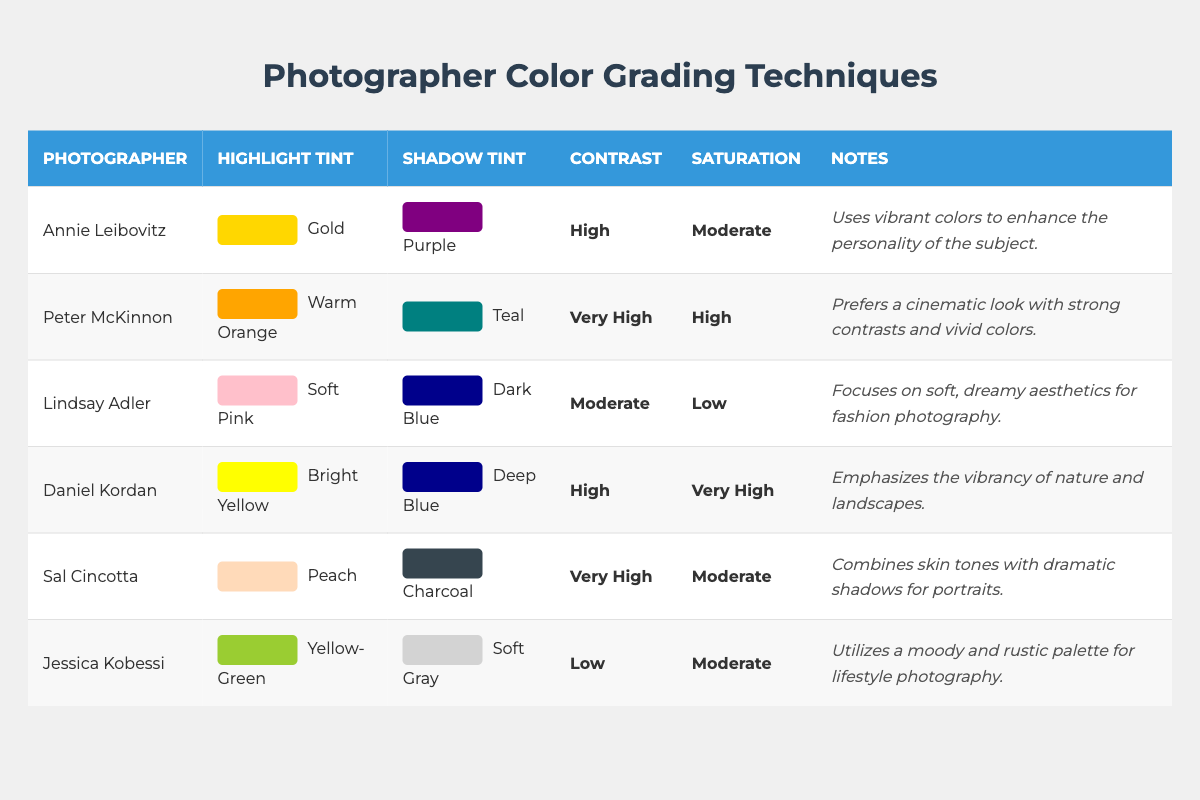What highlight tint does Annie Leibovitz use? Referring to the table, locate Annie Leibovitz's row and read her highlight tint, which is listed as "Gold."
Answer: Gold Which photographer uses a very high contrast in their work? By scanning the contrast column in the table, we see that both Peter McKinnon and Sal Cincotta have "Very High" registered as their contrast level.
Answer: Peter McKinnon, Sal Cincotta What is the saturation level used by Lindsay Adler? Check Lindsay Adler's row in the table to find her saturation level, which is specified as "Low."
Answer: Low Is Daniel Kordan's shadow tint deeper than that of Jessica Kobessi? By examining the shadow tint columns, Daniel Kordan has "Deep Blue" while Jessica Kobessi has "Soft Gray." Deep Blue is typically regarded as darker than Soft Gray.
Answer: Yes How many photographers use a highlight tint that includes the color "Yellow"? Count the instances in the highlight tint column that include "Yellow." Daniel Kordan and Jessica Kobessi both have "Yellow" (Bright Yellow and Yellow-Green).
Answer: 2 What is the main focus of Lindsay Adler's color grading technique according to the notes? Review the notes in Lindsay Adler's row where it states she "focuses on soft, dreamy aesthetics for fashion photography."
Answer: Soft, dreamy aesthetics for fashion photography Which two photographers have a moderate saturation level? Look at the saturation column and find those with "Moderate," which are Annie Leibovitz and Sal Cincotta.
Answer: Annie Leibovitz, Sal Cincotta What is the difference in highlight tints between Peter McKinnon and Sal Cincotta? The highlight tint for Peter McKinnon is "Warm Orange," and for Sal Cincotta, it is "Peach." The two colors are visually different, with the main distinction being one is orange and the other is peach.
Answer: Warm Orange vs. Peach If we consider all photographers, who has the highest saturation level? Check the saturation column for the highest value, where Daniel Kordan is noted to have "Very High," which is the highest compared to others.
Answer: Daniel Kordan What common color grading technique is used by both Annie Leibovitz and Jessica Kobessi? In the highlight tint column, both photographers utilize tints that include warm colors; Annie has "Gold," and Jessica has "Yellow-Green." This shows a tendency towards vibrant shades.
Answer: Warm colors (Gold, Yellow-Green) 